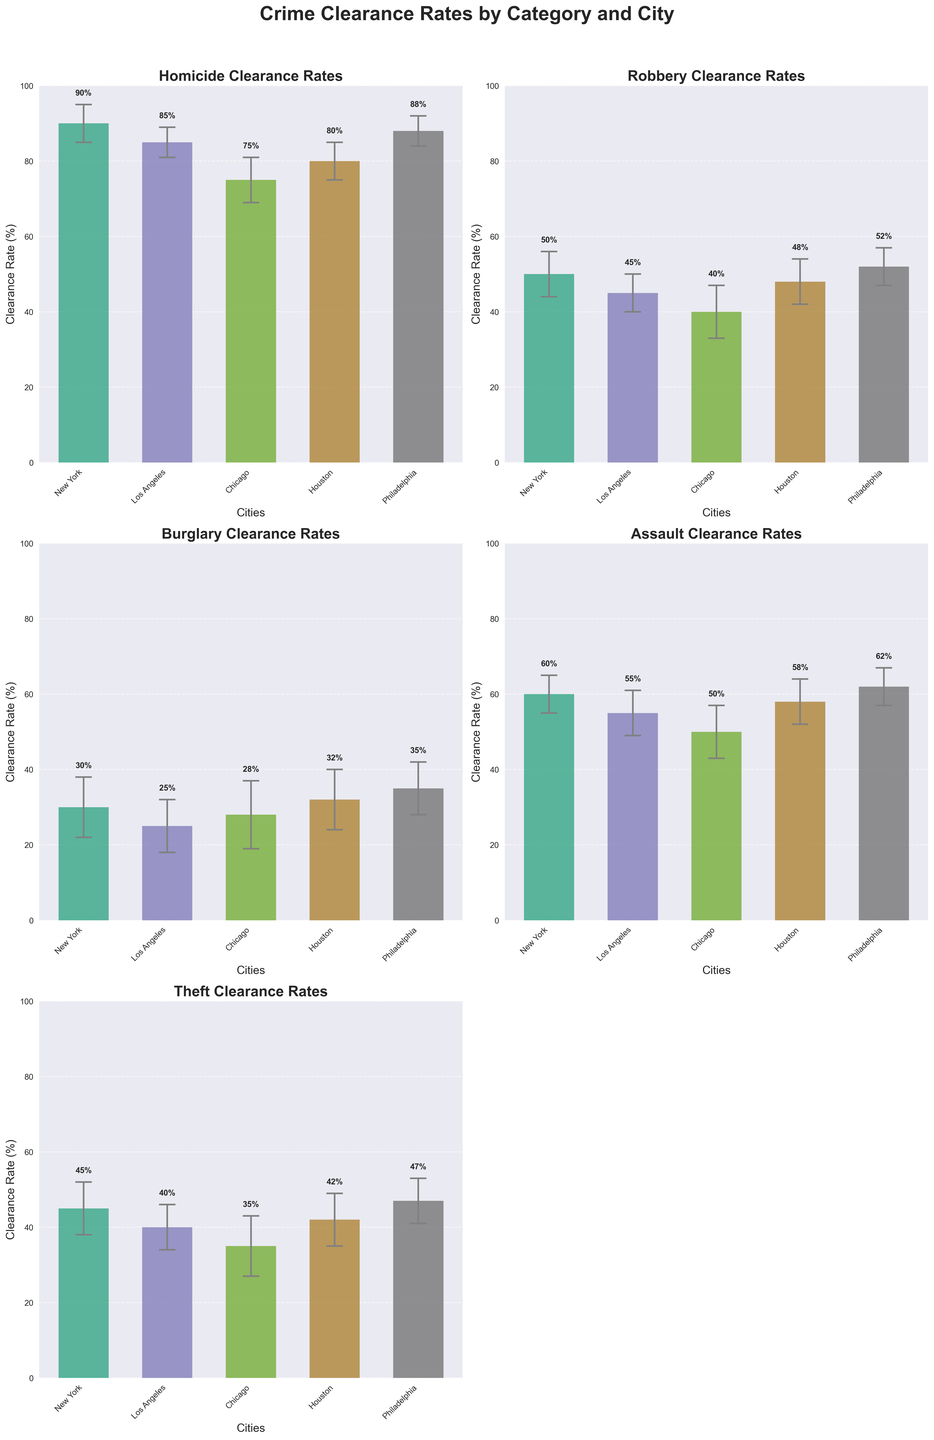What is the clearance rate for homicides in New York? Locate the "Homicide Clearance Rates" subplot, then look at the bar corresponding to New York, which is labelled along the x-axis. The height of the bar indicates the clearance rate.
Answer: 90% How does the clearance rate for robberies compare between New York and Philadelphia? Locate the "Robbery Clearance Rates" subplot, then compare the heights of the bars for New York and Philadelphia. The bar for New York is at 50%, and the bar for Philadelphia is at 52%.
Answer: Philadelphia is higher Which city has the highest clearance rate for burglaries? Locate the "Burglary Clearance Rates" subplot, then identify the city with the tallest bar. Philadelphia has the tallest bar at 35%.
Answer: Philadelphia What is the error margin for assaults in Chicago? Locate the "Assault Clearance Rates" subplot, then look at the bar corresponding to Chicago. The error margin is indicated by the vertical line (error bar) above and below the bar. According to the data, it is 7%.
Answer: 7% Which crime category has the largest error margin variation within a city across all categories? Compare the length of the error bars across all subplots for each city. Burglary in Chicago has a particularly large error margin of 9%.
Answer: Burglary in Chicago What is the difference in clearance rate for thefts between New York and Houston? Locate the "Theft Clearance Rates" subplot, then look at the bars for New York and Houston. The clearance rate for New York is 45%, and for Houston, it is 42%. The difference is 45% - 42% = 3%.
Answer: 3% Are there any categories where Los Angeles has the highest clearance rate compared to other cities? For each subplot, compare the bar height for Los Angeles against other cities. Los Angeles does not have the highest clearance rate in any category.
Answer: No What's the average clearance rate for assaults across all cities? Find the "Assault Clearance Rates" subplot and add up the clearance rates for all cities: (60% + 55% + 50% + 58% + 62%) = 285%. Then, divide by the number of cities, which is 5. The average is 285% / 5 = 57%.
Answer: 57% Which city has the lowest clearance rate for homicides? Locate the "Homicide Clearance Rates" subplot and identify the city with the shortest bar. Chicago has the shortest bar at 75%.
Answer: Chicago 